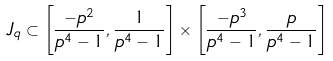<formula> <loc_0><loc_0><loc_500><loc_500>J _ { q } \subset \left [ \frac { - p ^ { 2 } } { p ^ { 4 } - 1 } , \frac { 1 } { p ^ { 4 } - 1 } \right ] \times \left [ \frac { - p ^ { 3 } } { p ^ { 4 } - 1 } , \frac { p } { p ^ { 4 } - 1 } \right ]</formula> 